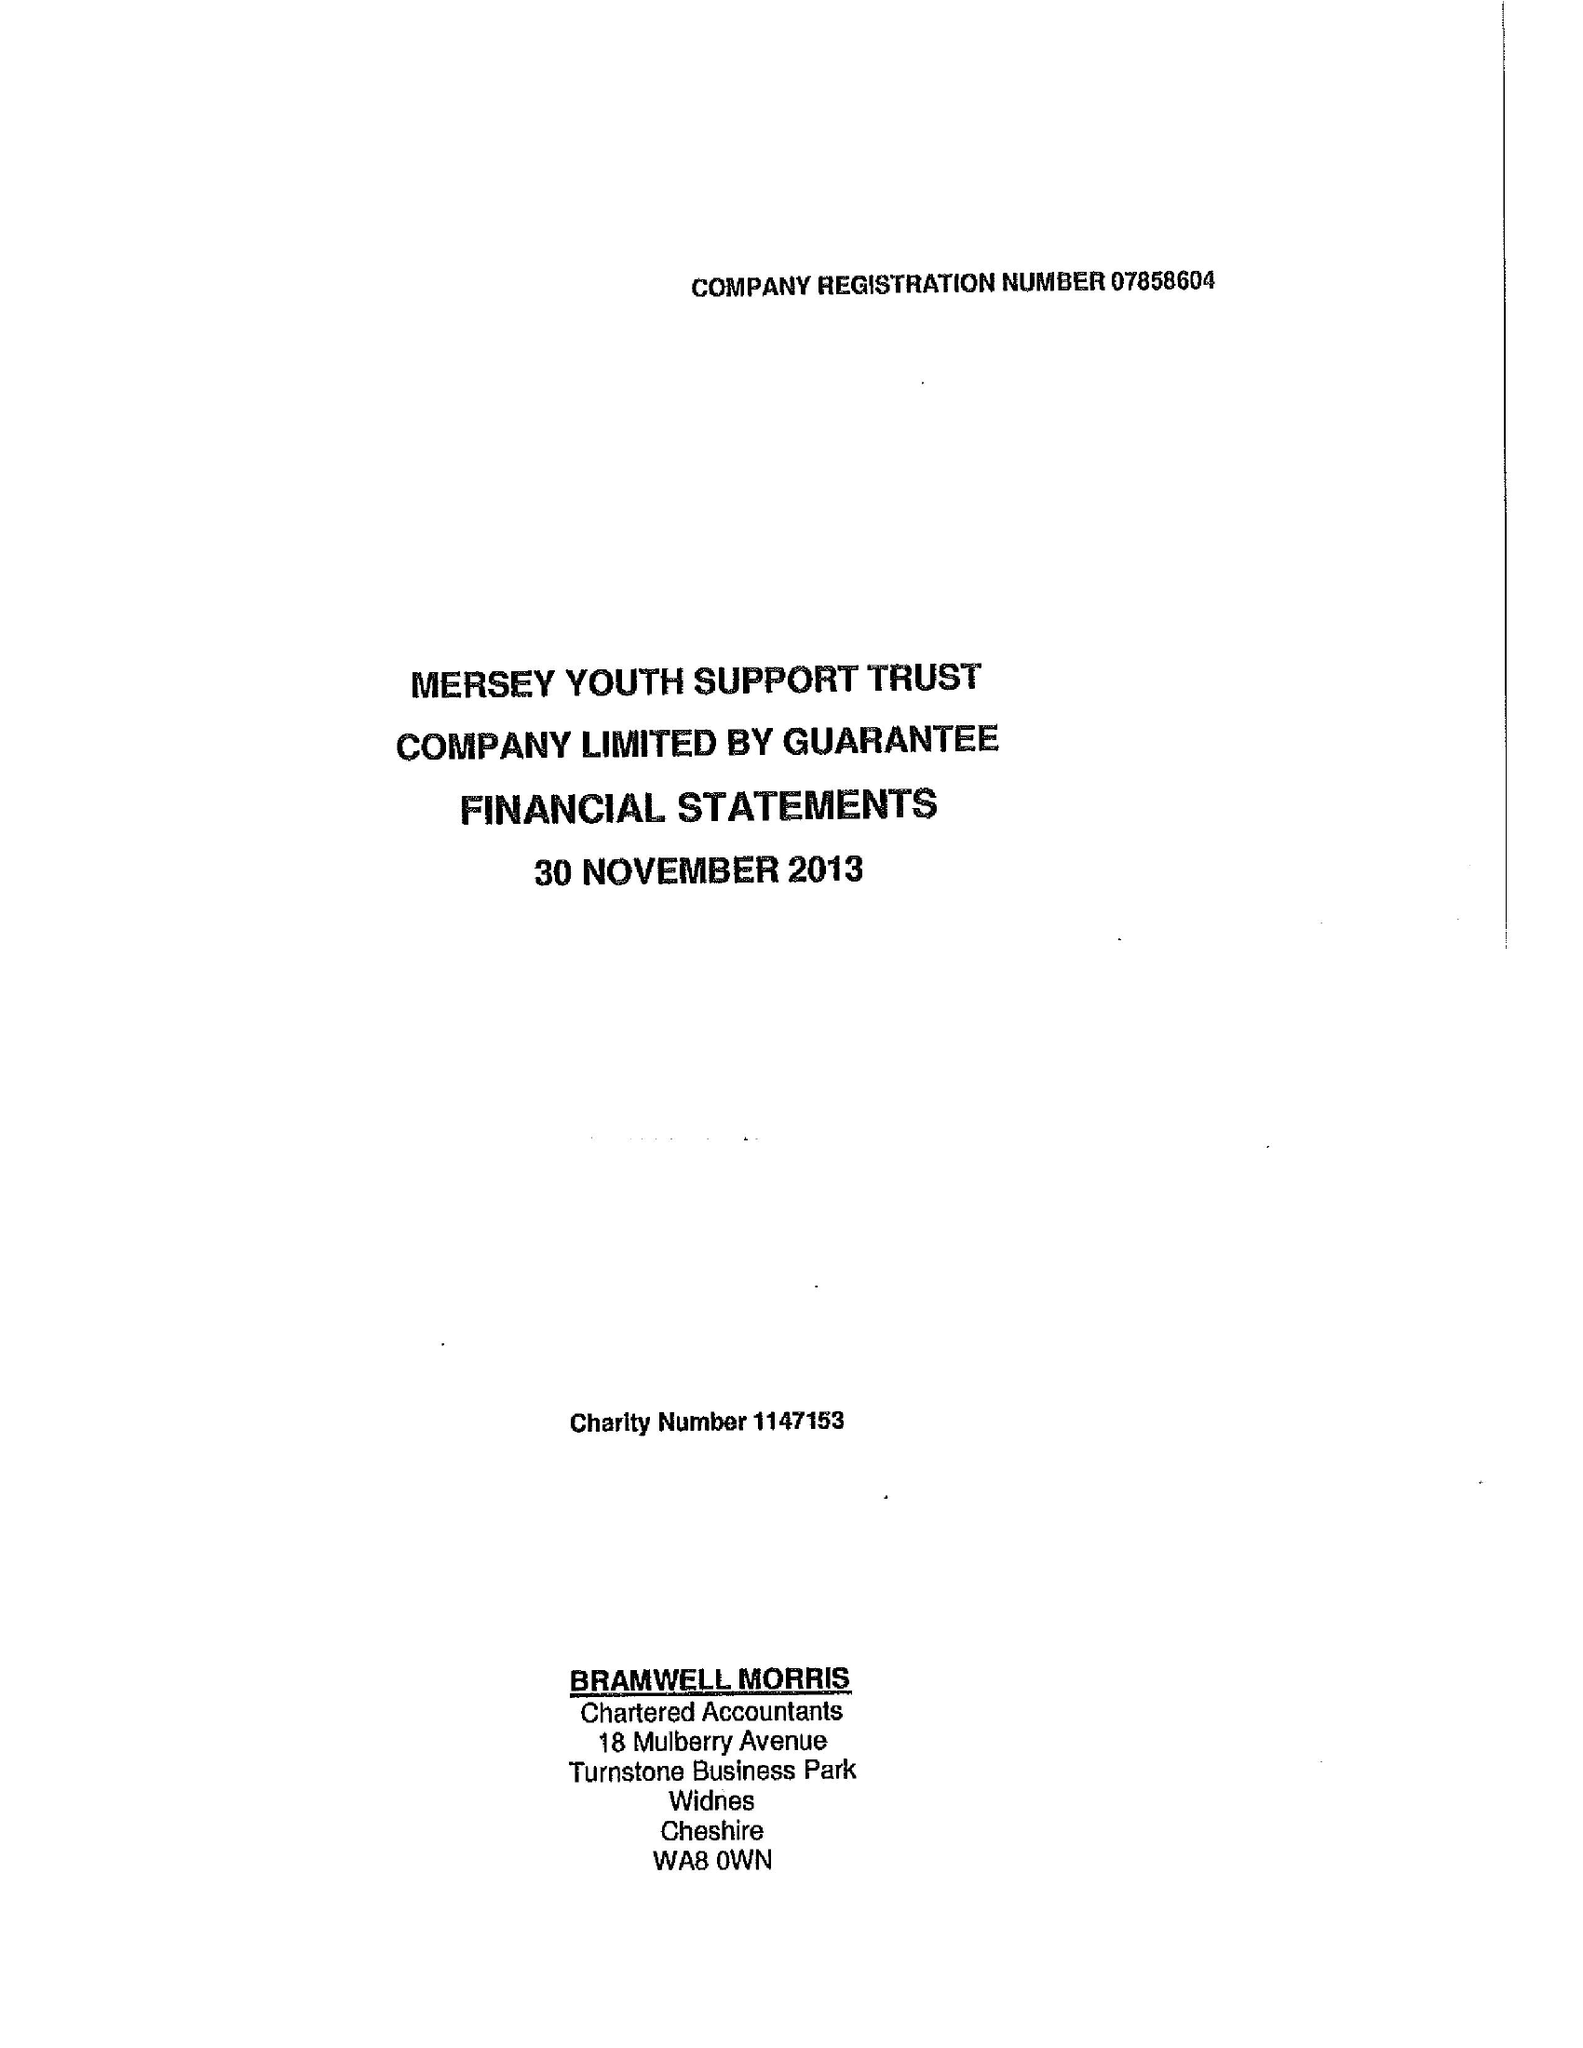What is the value for the income_annually_in_british_pounds?
Answer the question using a single word or phrase. 68479.00 